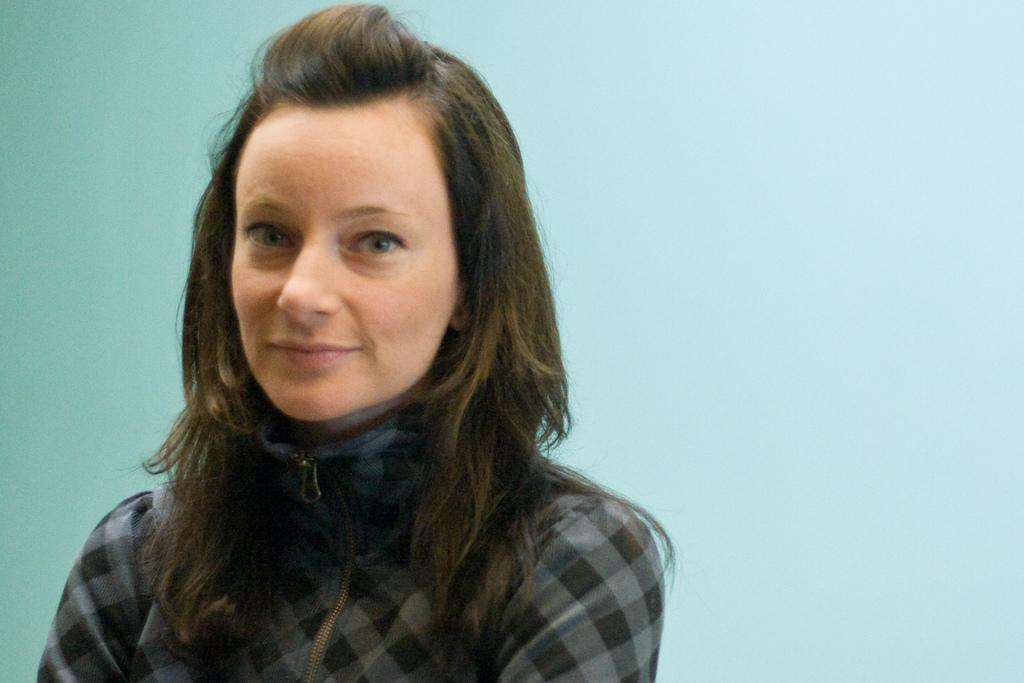What is the main subject of the image? The main subject of the image is a woman. Can you describe the woman's attire in the image? The woman is wearing a black and grey dress in the image. What type of account does the woman have in the image? There is no mention of an account in the image, as it features a woman wearing a black and grey dress. Is the woman a maid in the image? There is no indication in the image that the woman is a maid. 